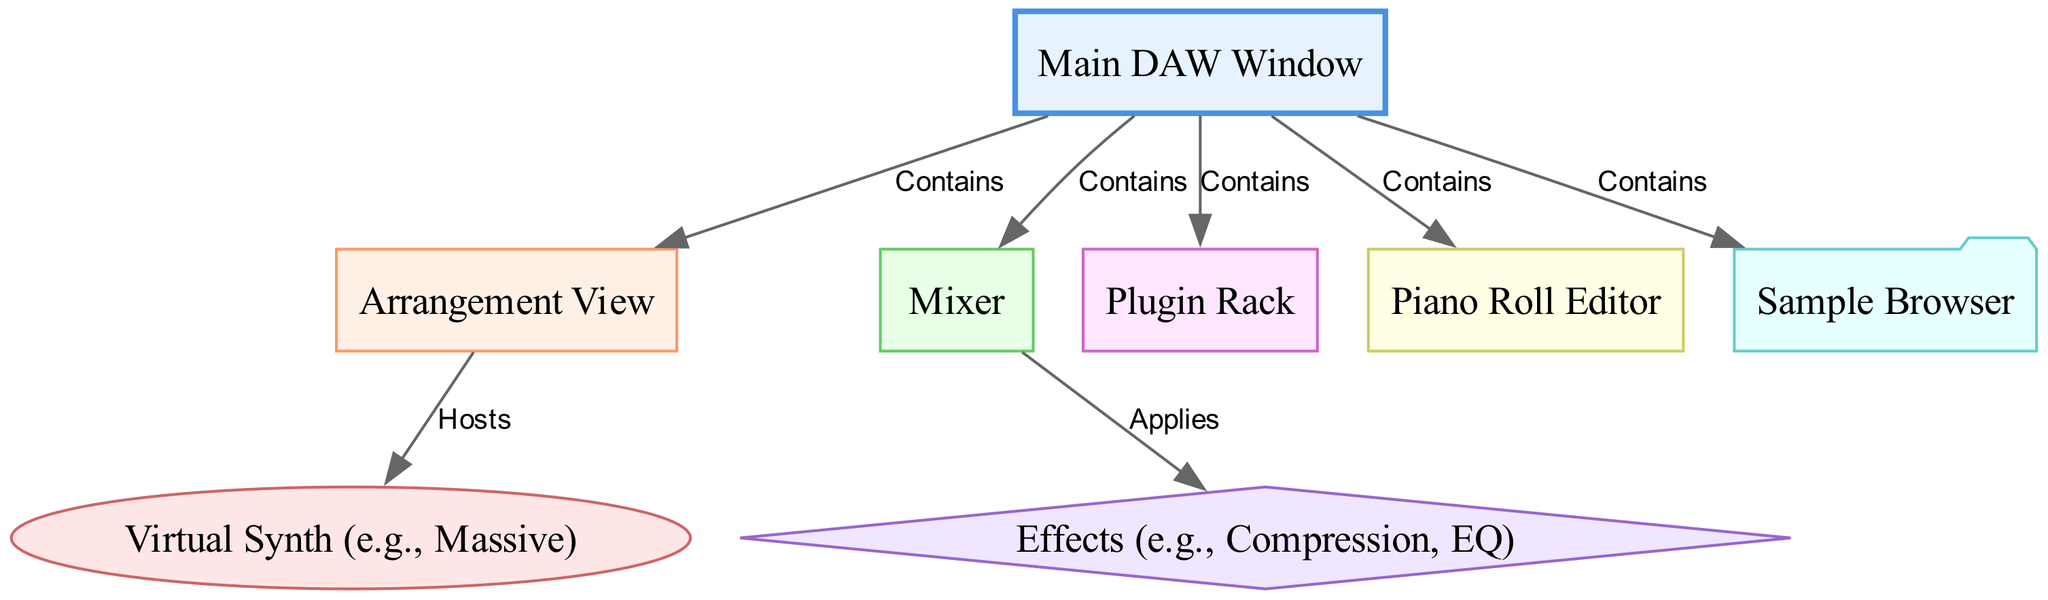What is the main window in the DAW layout? The main window is labeled as "Main DAW Window" and is at the top of the diagram, signifying it holds all other components.
Answer: Main DAW Window How many nodes are there in the diagram? By counting each labeled node (there are 8 different components including the main window), we find a total of 8 nodes.
Answer: 8 What does the arrangement view contain? The arrangement view is shown to be a component of the main DAW window that hosts the virtual synth.
Answer: Virtual Synth (e.g., Massive) What does the mixer apply to? The mixer node has an edge indicating that it applies effects, specifically compression or EQ, showing the relationship between these components.
Answer: Effects (e.g., Compression, EQ) Which node is shown as a folder in the diagram? The sample browser is visually distinct, represented as a folder to indicate its function in the DAW layout.
Answer: Sample Browser What is the relationship between the main window and the plugin rack? The relationship is labeled as "Contains" which indicates the main window houses the plugin rack as one of its components.
Answer: Contains How many edges are connecting nodes in this diagram? By counting the lines (edges) connecting the nodes, we see there are 6 edges that outline the relationships between the components.
Answer: 6 Which component does the effects node connect to? The effects node specifically connects to the mixer node through the labeled edge "Applies," representing how effects are utilized in the mixing process.
Answer: Mixer What type of component is the piano roll editor? The piano roll is classified as a rectangle in the diagram, indicating it is a part of the DAW's interface structure used for musical sequencing.
Answer: Rectangle 